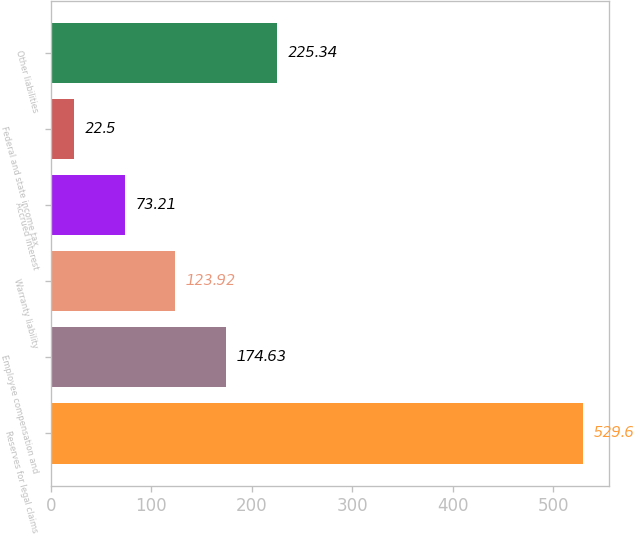Convert chart. <chart><loc_0><loc_0><loc_500><loc_500><bar_chart><fcel>Reserves for legal claims<fcel>Employee compensation and<fcel>Warranty liability<fcel>Accrued interest<fcel>Federal and state income tax<fcel>Other liabilities<nl><fcel>529.6<fcel>174.63<fcel>123.92<fcel>73.21<fcel>22.5<fcel>225.34<nl></chart> 